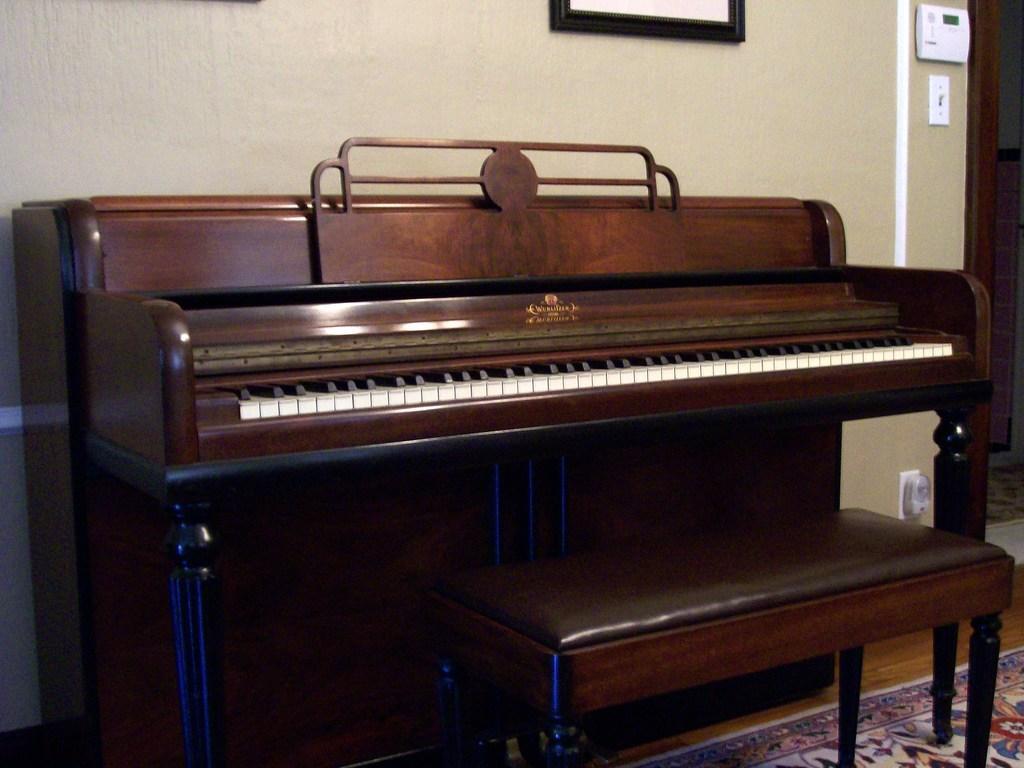Can you describe this image briefly? The image is taken inside a room. There is a wall painting attached to a wall and there is a piano, a chair in the image. 